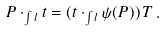Convert formula to latex. <formula><loc_0><loc_0><loc_500><loc_500>P \cdot _ { \int l } t = ( t \cdot _ { \int l } \psi ( P ) ) \, T \, .</formula> 